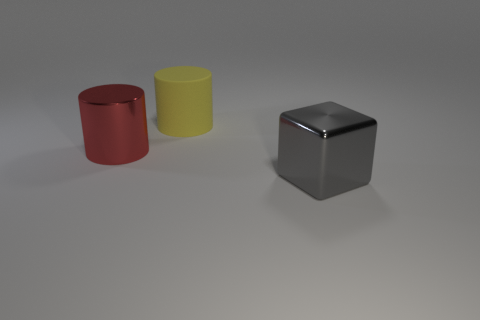How many blue metal cylinders are the same size as the red cylinder? 0 